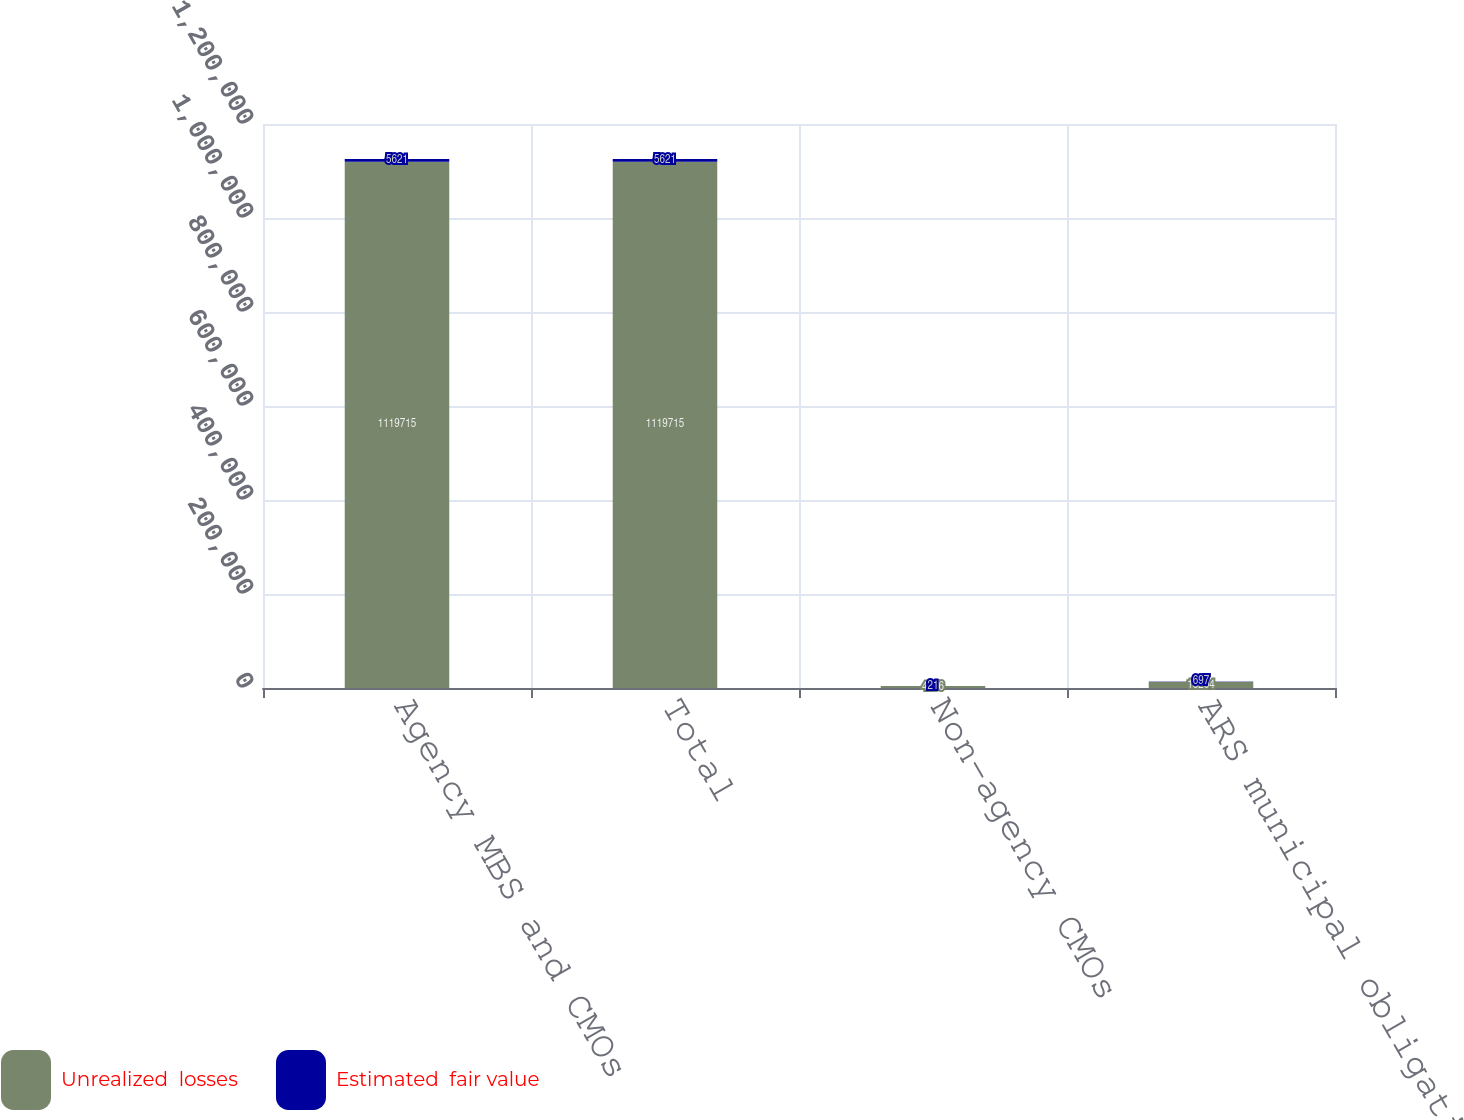Convert chart. <chart><loc_0><loc_0><loc_500><loc_500><stacked_bar_chart><ecel><fcel>Agency MBS and CMOs<fcel>Total<fcel>Non-agency CMOs<fcel>ARS municipal obligations<nl><fcel>Unrealized  losses<fcel>1.11972e+06<fcel>1.11972e+06<fcel>4256<fcel>13204<nl><fcel>Estimated  fair value<fcel>5621<fcel>5621<fcel>21<fcel>697<nl></chart> 